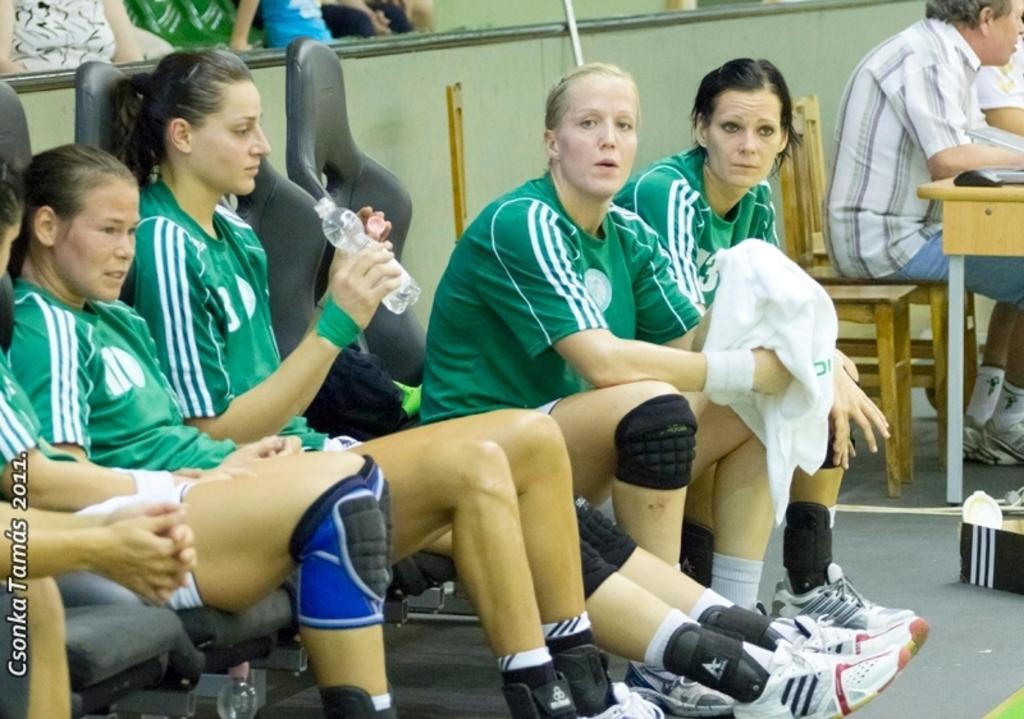In one or two sentences, can you explain what this image depicts? In this image I see few women who are wearing same jersey and I see that this woman is holding a bottle in her hand and this woman is holding a white color cloth in her hands and I see that they are sitting on chairs and I see a man over here who is sitting on a chair and I see a table. In the background I see the wall and I see few people over here and I see the path and I see the watermark over here. 